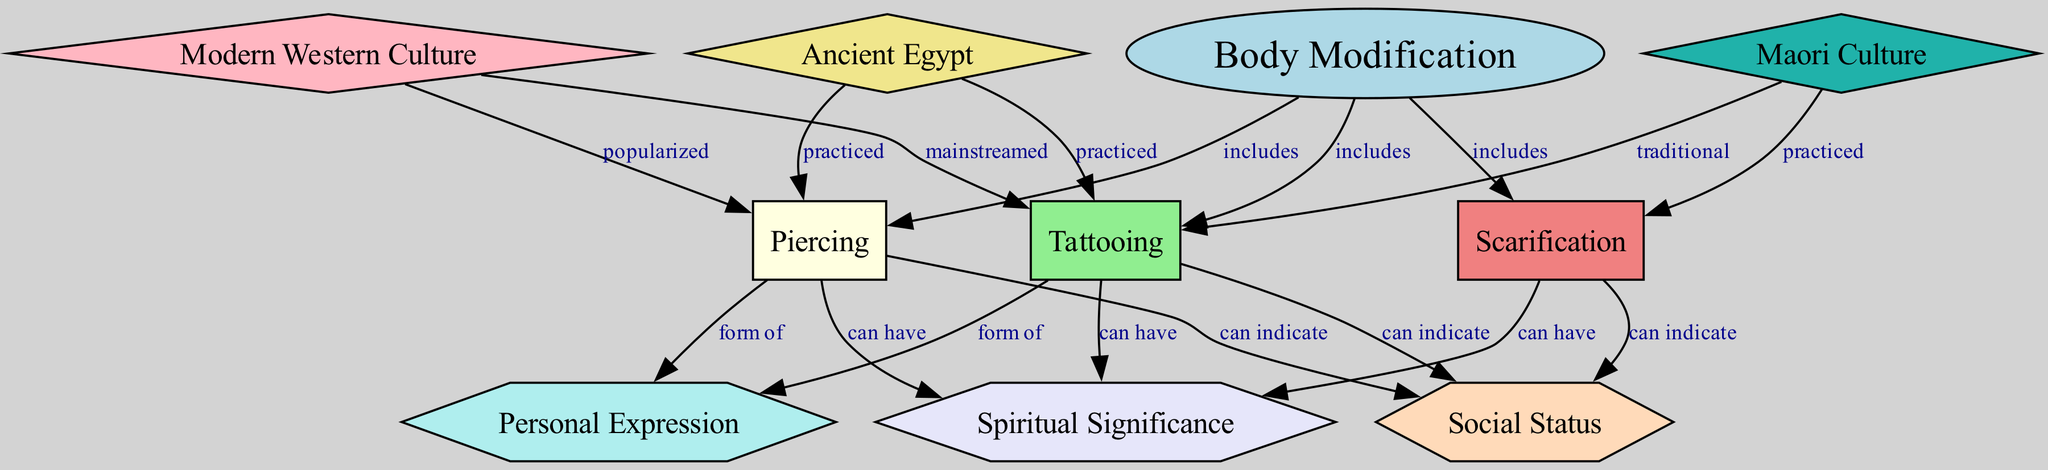What are the three types of body modification included in the diagram? The diagram specifies "Piercing," "Tattooing," and "Scarification" as the three types of body modification, which are all connected to the central node "Body Modification" with the label "includes."
Answer: Piercing, Tattooing, Scarification Which culture is associated with the traditional practice of tattooing? The diagram shows that "Maori Culture" has a connection to "Tattooing" labeled as "traditional." Thus, this culture is specifically linked to traditional tattooing practices.
Answer: Maori Culture How many edges connect the "Modern Western Culture" node to other nodes? By counting the connections in the diagram, "Modern Western Culture" is linked to two other nodes: it is connected to "Piercing" with the label "popularized" and to "Tattooing" with the label "mainstreamed." Thus, the total is two edges.
Answer: 2 What significance can piercing have according to the diagram? The diagram indicates that "Piercing" can have "Spiritual Significance," "Social Status," and is a "form of" "Personal Expression." To determine the significance listed, we can simply refer to the connections related to "Piercing" in the diagram.
Answer: Spiritual Significance, Social Status, Personal Expression In which ancient civilization was piercing practiced? The diagram connects "Ancient Egypt" to both "Piercing" and "Tattooing," showing that these practices were part of the ancient civilization. The specific connection for piercing points directly to "Ancient Egypt."
Answer: Ancient Egypt What are the three categories that body modifications can indicate? The diagram connects "Piercing," "Tattooing," and "Scarification" to "Social Status" with the label "can indicate." Therefore, body modifications can indicate three things, and they all fall under the same category.
Answer: Social Status Which node represents the main form of personal expression in body modification? The diagram shows that both "Piercing" and "Tattooing" have connections to "Personal Expression" with the label "form of." Thus, the main forms of personal expression in body modification practices are represented by these nodes.
Answer: Piercing, Tattooing What cultural practice is linked to scarification? The diagram illustrates that "Scarification" is practiced within "Maori Culture." The connection is clearly indicated in the diagram with the label "practiced."
Answer: Maori Culture 